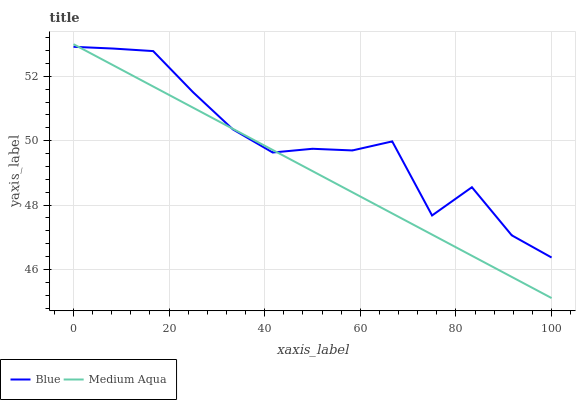Does Medium Aqua have the minimum area under the curve?
Answer yes or no. Yes. Does Blue have the maximum area under the curve?
Answer yes or no. Yes. Does Medium Aqua have the maximum area under the curve?
Answer yes or no. No. Is Medium Aqua the smoothest?
Answer yes or no. Yes. Is Blue the roughest?
Answer yes or no. Yes. Is Medium Aqua the roughest?
Answer yes or no. No. Does Medium Aqua have the lowest value?
Answer yes or no. Yes. Does Medium Aqua have the highest value?
Answer yes or no. Yes. Does Blue intersect Medium Aqua?
Answer yes or no. Yes. Is Blue less than Medium Aqua?
Answer yes or no. No. Is Blue greater than Medium Aqua?
Answer yes or no. No. 